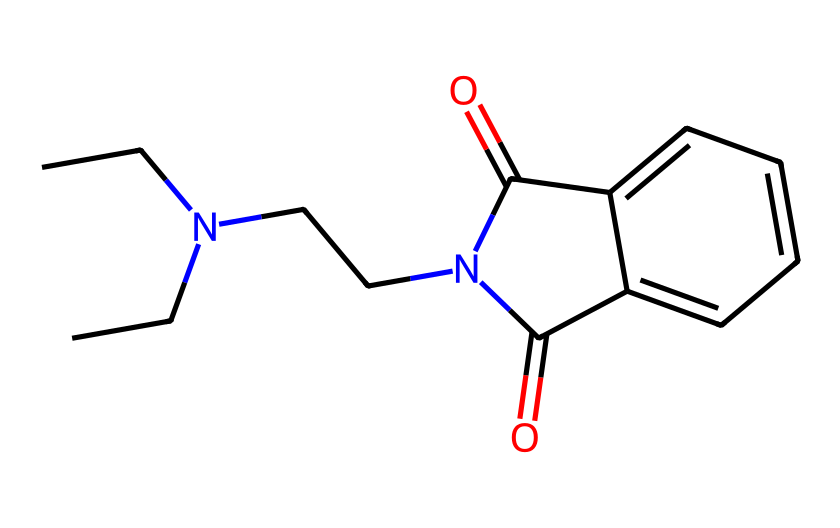What is the total number of carbon atoms in the chemical? By analyzing the SMILES representation, we can identify the number of carbon atoms present. The "C" indicates carbon and counting all instances in the structure gives a total of eight carbon atoms.
Answer: eight How many nitrogen atoms are in this molecule? In the provided SMILES structure, "N" indicates the presence of nitrogen. There are two occurrences of "N" in the structure, which means there are two nitrogen atoms.
Answer: two What is the functional group indicated by the "O=C" in the structure? The "O=C" pattern represents a carbonyl group, which is characteristic of ketones or aldehydes; in this case, it signifies that the compound contains a carbonyl functional group.
Answer: carbonyl Does this chemical structure have any aromatic rings? The presence of "c" in the SMILES notation indicates carbon atoms that are part of aromatic rings. There are also π bonds implied by the alternating double bonds, confirming that the molecule has aromatic properties.
Answer: yes What type of chemical reactions is this molecule likely suitable for? The carbonyl and amine groups make this molecule capable of undergoing various reactions such as condensation and electrophilic reactions, making it versatile in organic synthesis.
Answer: electrophilic reactions What is the molecular weight of this chemical? To calculate the molecular weight, you sum the atomic weights of all atoms in the structure. Counting the atoms gives us 16 carbons, 21 hydrogens, 2 nitrogens, and 2 oxygens, resulting in a molecular weight of approximately 273.34 g/mol.
Answer: approximately 273.34 g/mol Is this compound fluorescent based on its structure? The presence of the carbonyl group and aromatic rings typically indicates the potential for fluorescence, especially in molecules designed for glow sticks; thus, it's reasonable to conclude that this compound may possess fluorescent properties.
Answer: yes 